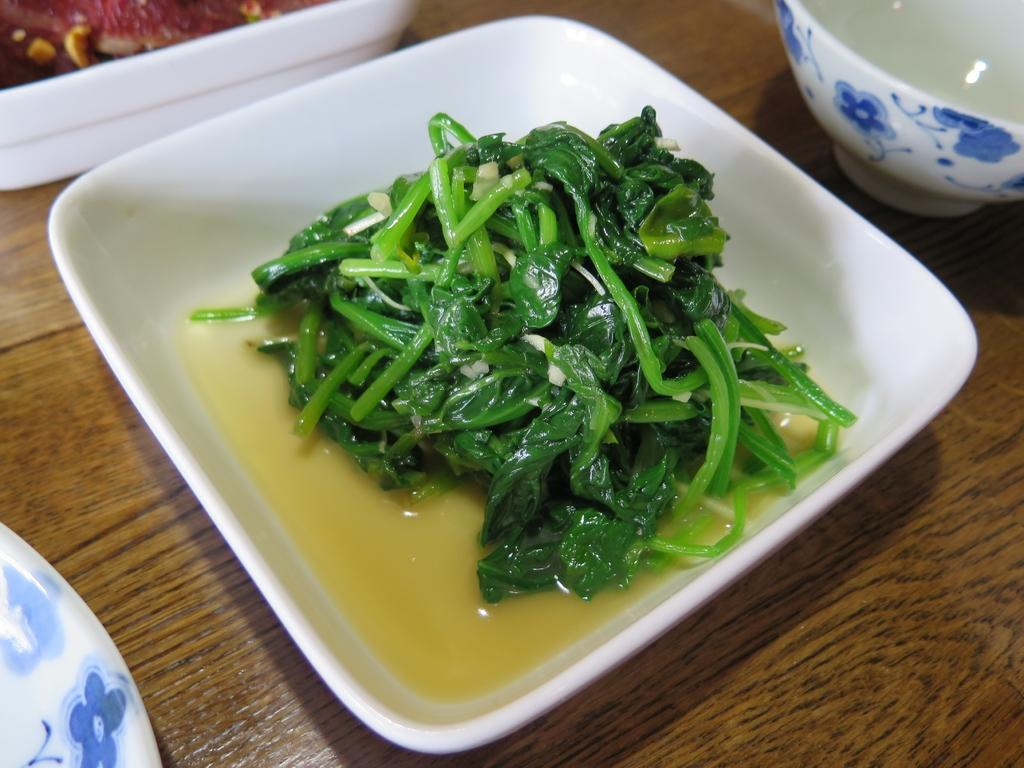What type of surface is visible in the image? There is a wooden surface in the image. What is placed on the wooden surface? There is a bowl with a food item on the wooden surface. How many bowls are visible on the wooden surface? There are additional bowls on the wooden surface. What other items can be seen on the wooden surface? There are other unspecified items on the wooden surface. What type of tax form is visible on the wooden surface in the image? There is no tax form visible on the wooden surface in the image. What kind of pet can be seen interacting with the food items on the wooden surface? There is no pet present in the image; it only features a wooden surface with various items. 